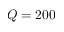Convert formula to latex. <formula><loc_0><loc_0><loc_500><loc_500>Q = 2 0 0</formula> 